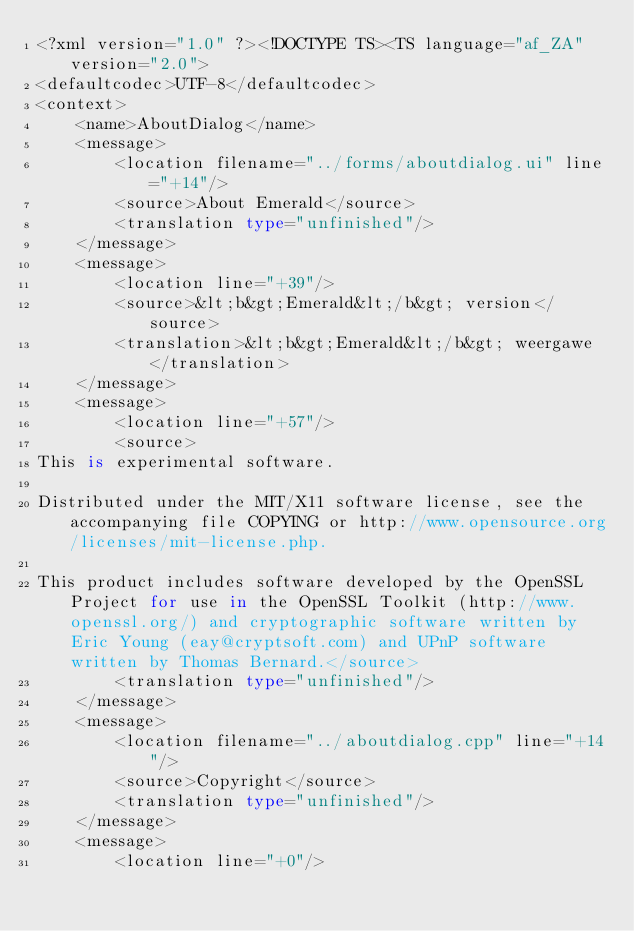<code> <loc_0><loc_0><loc_500><loc_500><_TypeScript_><?xml version="1.0" ?><!DOCTYPE TS><TS language="af_ZA" version="2.0">
<defaultcodec>UTF-8</defaultcodec>
<context>
    <name>AboutDialog</name>
    <message>
        <location filename="../forms/aboutdialog.ui" line="+14"/>
        <source>About Emerald</source>
        <translation type="unfinished"/>
    </message>
    <message>
        <location line="+39"/>
        <source>&lt;b&gt;Emerald&lt;/b&gt; version</source>
        <translation>&lt;b&gt;Emerald&lt;/b&gt; weergawe</translation>
    </message>
    <message>
        <location line="+57"/>
        <source>
This is experimental software.

Distributed under the MIT/X11 software license, see the accompanying file COPYING or http://www.opensource.org/licenses/mit-license.php.

This product includes software developed by the OpenSSL Project for use in the OpenSSL Toolkit (http://www.openssl.org/) and cryptographic software written by Eric Young (eay@cryptsoft.com) and UPnP software written by Thomas Bernard.</source>
        <translation type="unfinished"/>
    </message>
    <message>
        <location filename="../aboutdialog.cpp" line="+14"/>
        <source>Copyright</source>
        <translation type="unfinished"/>
    </message>
    <message>
        <location line="+0"/></code> 